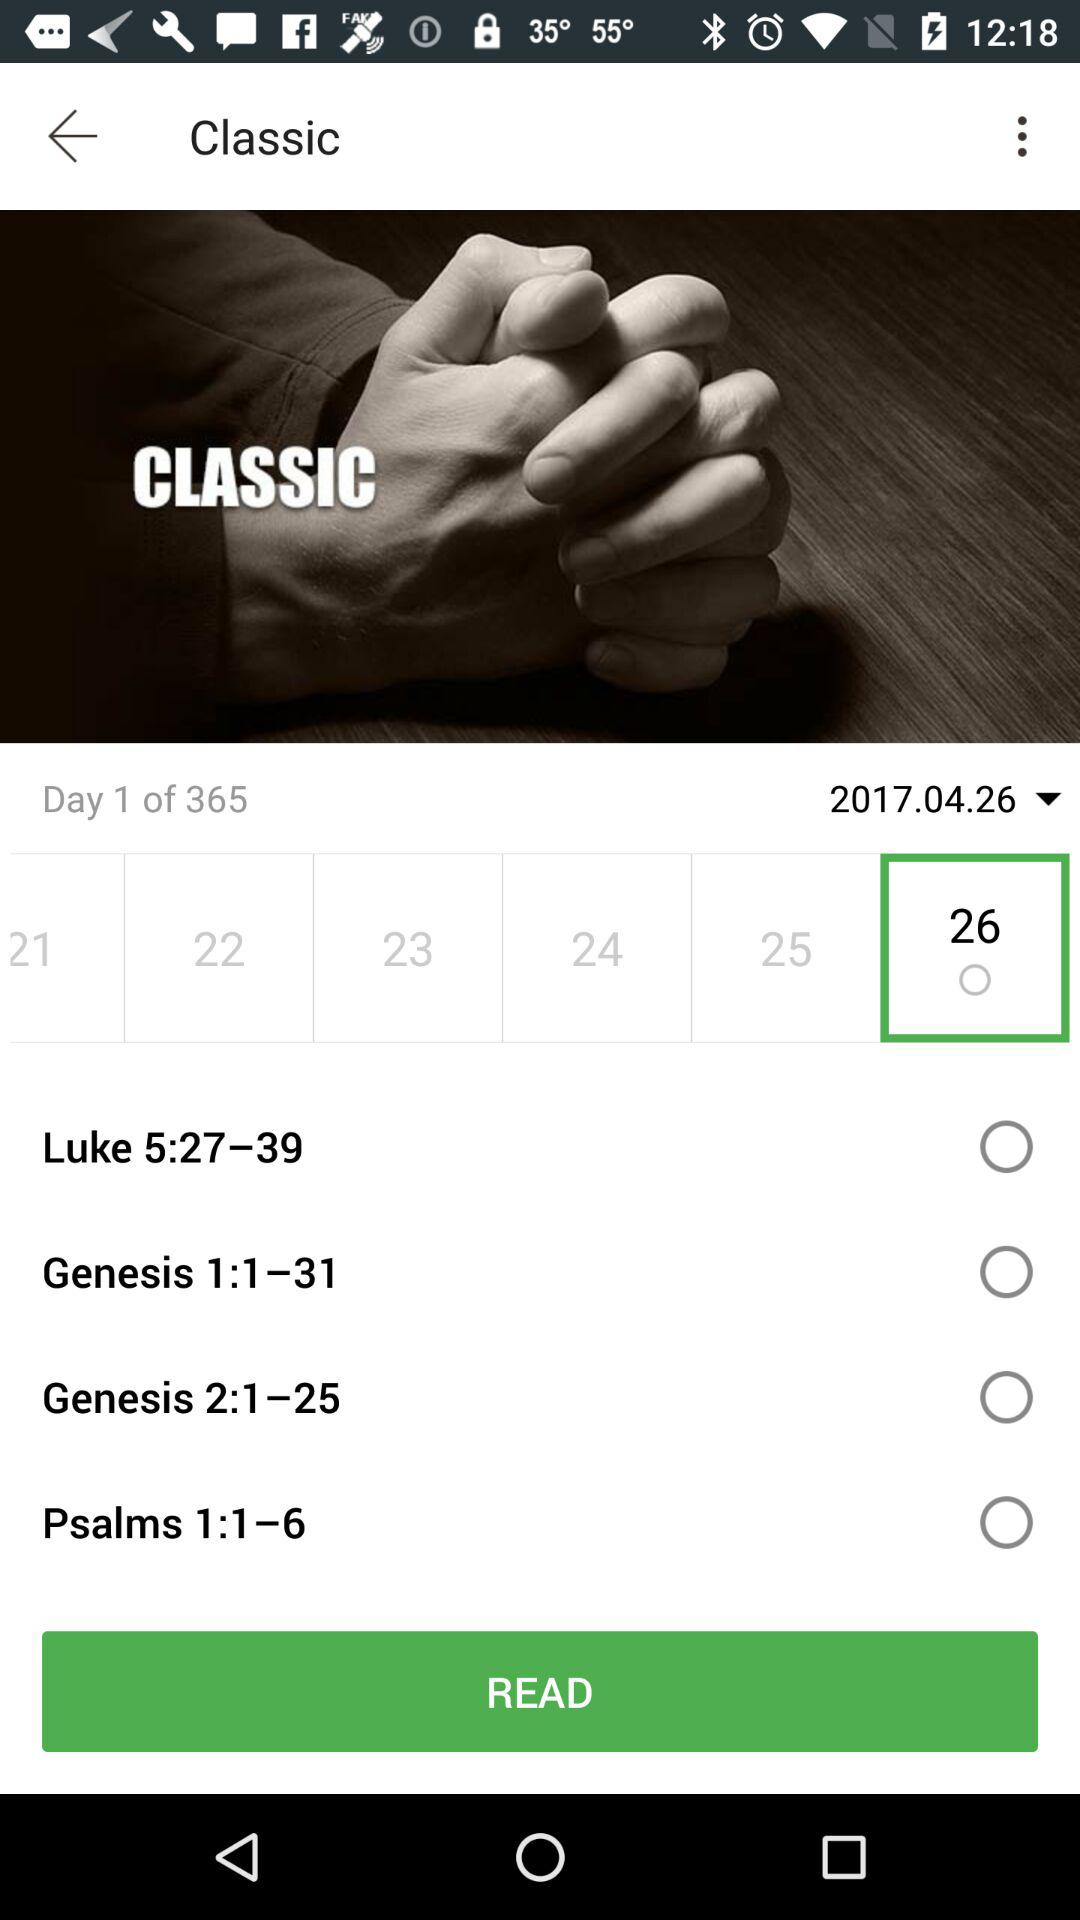Which date has been selected? The selected date is April 26, 2017. 